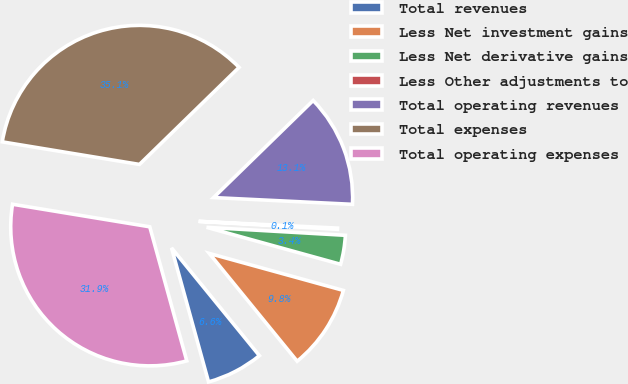<chart> <loc_0><loc_0><loc_500><loc_500><pie_chart><fcel>Total revenues<fcel>Less Net investment gains<fcel>Less Net derivative gains<fcel>Less Other adjustments to<fcel>Total operating revenues<fcel>Total expenses<fcel>Total operating expenses<nl><fcel>6.6%<fcel>9.83%<fcel>3.37%<fcel>0.14%<fcel>13.07%<fcel>35.11%<fcel>31.88%<nl></chart> 